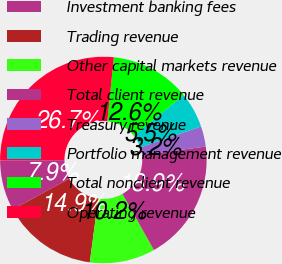Convert chart. <chart><loc_0><loc_0><loc_500><loc_500><pie_chart><fcel>Investment banking fees<fcel>Trading revenue<fcel>Other capital markets revenue<fcel>Total client revenue<fcel>Treasury revenue<fcel>Portfolio management revenue<fcel>Total nonclient revenue<fcel>Operating revenue<nl><fcel>7.89%<fcel>14.94%<fcel>10.24%<fcel>18.93%<fcel>3.19%<fcel>5.54%<fcel>12.59%<fcel>26.69%<nl></chart> 